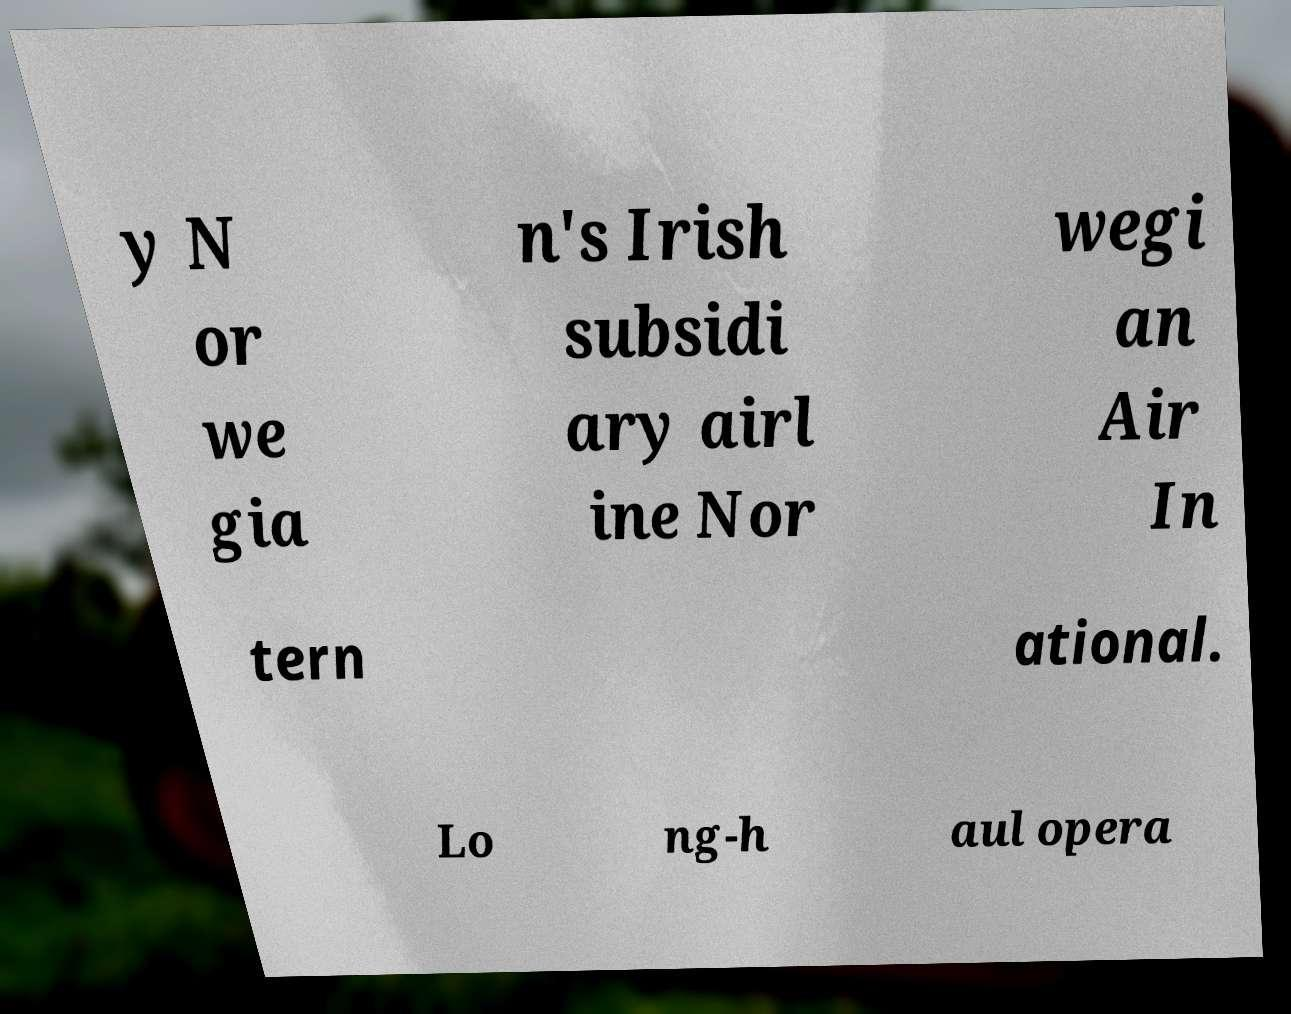Can you read and provide the text displayed in the image?This photo seems to have some interesting text. Can you extract and type it out for me? y N or we gia n's Irish subsidi ary airl ine Nor wegi an Air In tern ational. Lo ng-h aul opera 